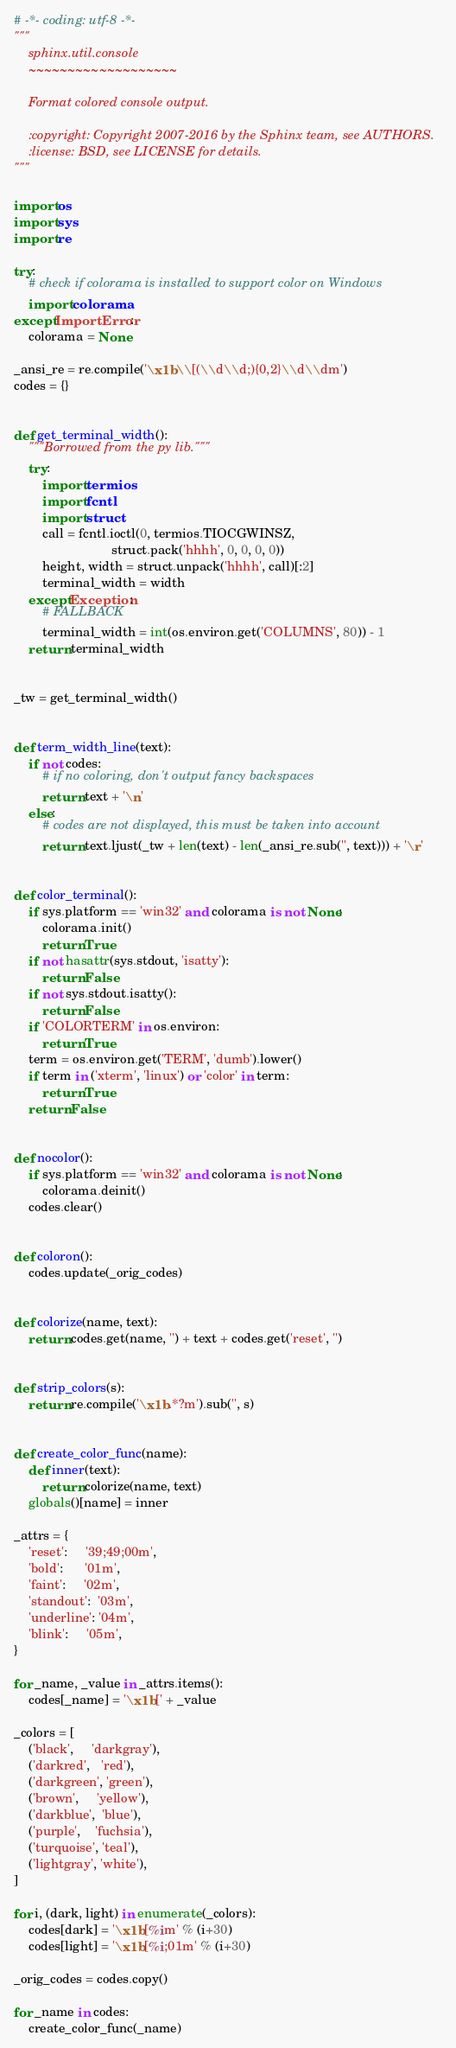Convert code to text. <code><loc_0><loc_0><loc_500><loc_500><_Python_># -*- coding: utf-8 -*-
"""
    sphinx.util.console
    ~~~~~~~~~~~~~~~~~~~

    Format colored console output.

    :copyright: Copyright 2007-2016 by the Sphinx team, see AUTHORS.
    :license: BSD, see LICENSE for details.
"""

import os
import sys
import re

try:
    # check if colorama is installed to support color on Windows
    import colorama
except ImportError:
    colorama = None

_ansi_re = re.compile('\x1b\\[(\\d\\d;){0,2}\\d\\dm')
codes = {}


def get_terminal_width():
    """Borrowed from the py lib."""
    try:
        import termios
        import fcntl
        import struct
        call = fcntl.ioctl(0, termios.TIOCGWINSZ,
                           struct.pack('hhhh', 0, 0, 0, 0))
        height, width = struct.unpack('hhhh', call)[:2]
        terminal_width = width
    except Exception:
        # FALLBACK
        terminal_width = int(os.environ.get('COLUMNS', 80)) - 1
    return terminal_width


_tw = get_terminal_width()


def term_width_line(text):
    if not codes:
        # if no coloring, don't output fancy backspaces
        return text + '\n'
    else:
        # codes are not displayed, this must be taken into account
        return text.ljust(_tw + len(text) - len(_ansi_re.sub('', text))) + '\r'


def color_terminal():
    if sys.platform == 'win32' and colorama is not None:
        colorama.init()
        return True
    if not hasattr(sys.stdout, 'isatty'):
        return False
    if not sys.stdout.isatty():
        return False
    if 'COLORTERM' in os.environ:
        return True
    term = os.environ.get('TERM', 'dumb').lower()
    if term in ('xterm', 'linux') or 'color' in term:
        return True
    return False


def nocolor():
    if sys.platform == 'win32' and colorama is not None:
        colorama.deinit()
    codes.clear()


def coloron():
    codes.update(_orig_codes)


def colorize(name, text):
    return codes.get(name, '') + text + codes.get('reset', '')


def strip_colors(s):
    return re.compile('\x1b.*?m').sub('', s)


def create_color_func(name):
    def inner(text):
        return colorize(name, text)
    globals()[name] = inner

_attrs = {
    'reset':     '39;49;00m',
    'bold':      '01m',
    'faint':     '02m',
    'standout':  '03m',
    'underline': '04m',
    'blink':     '05m',
}

for _name, _value in _attrs.items():
    codes[_name] = '\x1b[' + _value

_colors = [
    ('black',     'darkgray'),
    ('darkred',   'red'),
    ('darkgreen', 'green'),
    ('brown',     'yellow'),
    ('darkblue',  'blue'),
    ('purple',    'fuchsia'),
    ('turquoise', 'teal'),
    ('lightgray', 'white'),
]

for i, (dark, light) in enumerate(_colors):
    codes[dark] = '\x1b[%im' % (i+30)
    codes[light] = '\x1b[%i;01m' % (i+30)

_orig_codes = codes.copy()

for _name in codes:
    create_color_func(_name)
</code> 